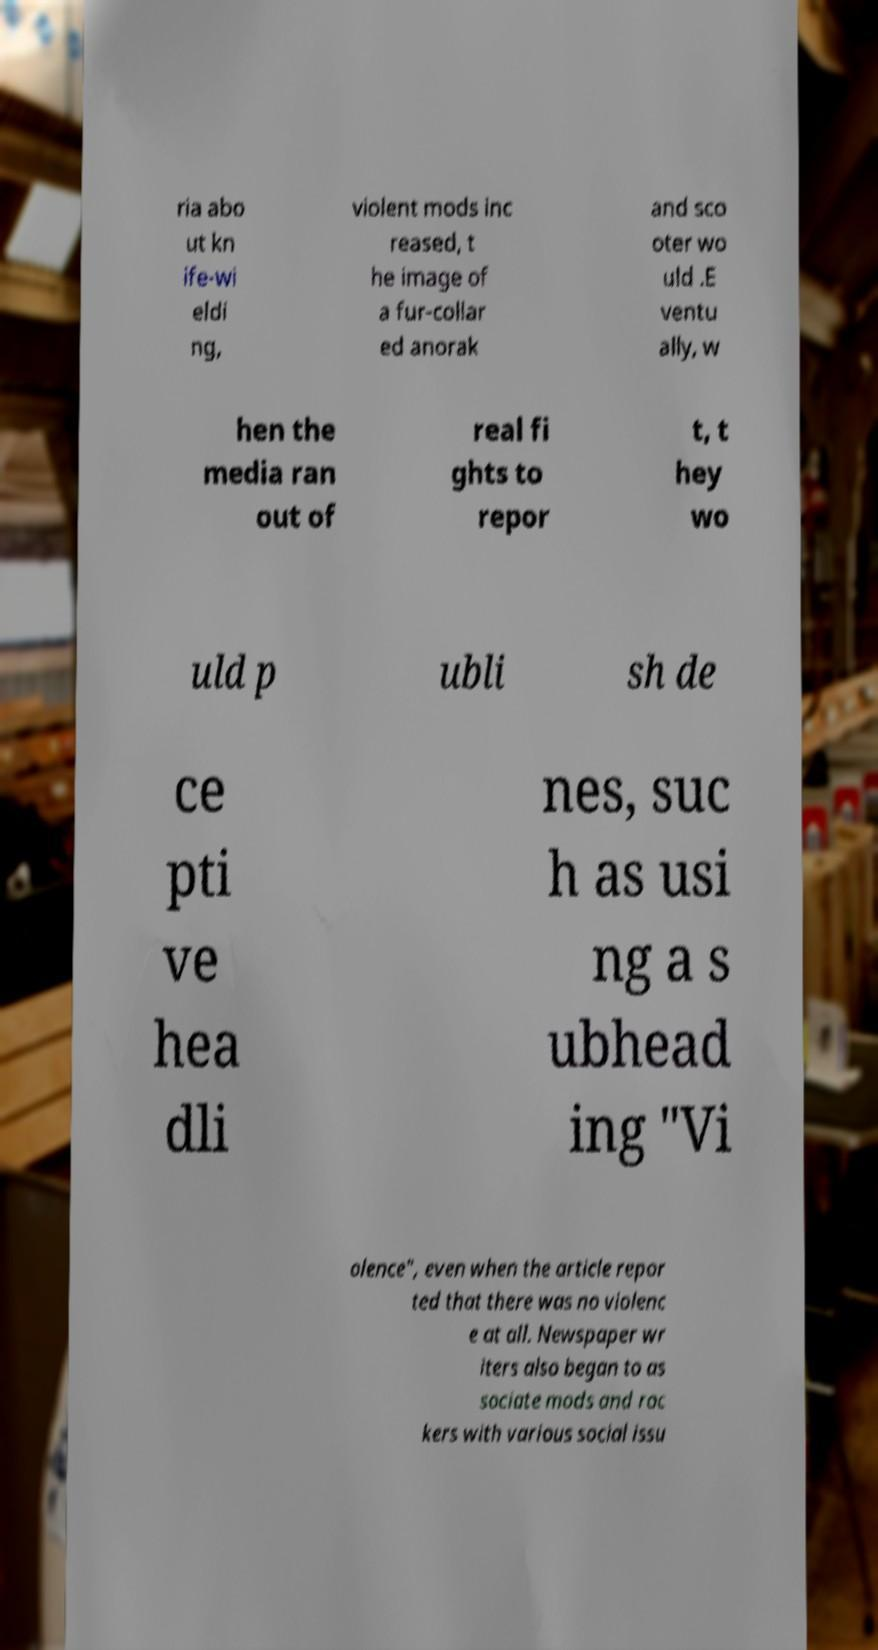I need the written content from this picture converted into text. Can you do that? ria abo ut kn ife-wi eldi ng, violent mods inc reased, t he image of a fur-collar ed anorak and sco oter wo uld .E ventu ally, w hen the media ran out of real fi ghts to repor t, t hey wo uld p ubli sh de ce pti ve hea dli nes, suc h as usi ng a s ubhead ing "Vi olence", even when the article repor ted that there was no violenc e at all. Newspaper wr iters also began to as sociate mods and roc kers with various social issu 